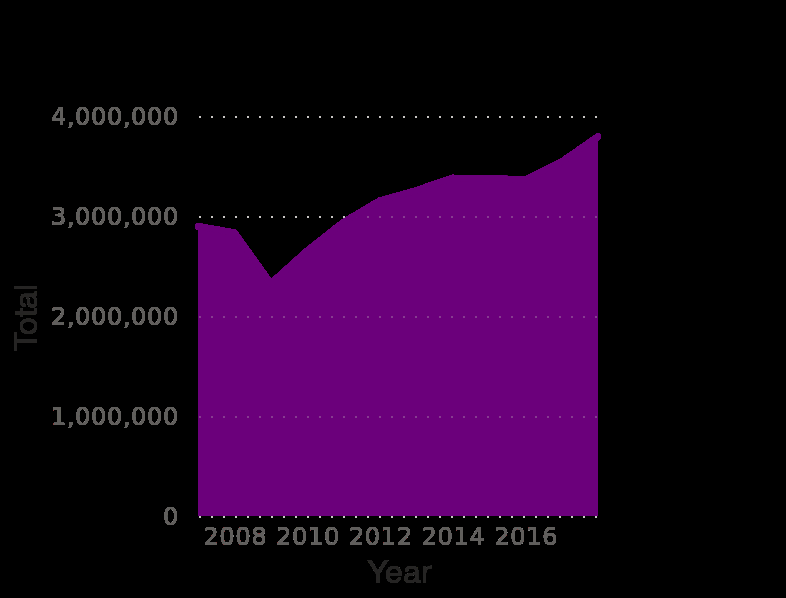<image>
Is the upward trend in 2015 steeper than the previous rise in the line? Yes, the upward trend in 2015 is sharper compared to the gradual rise before 2015. What is the range of years covered by the area plot? The range of years covered is from 2007 to 2018. 